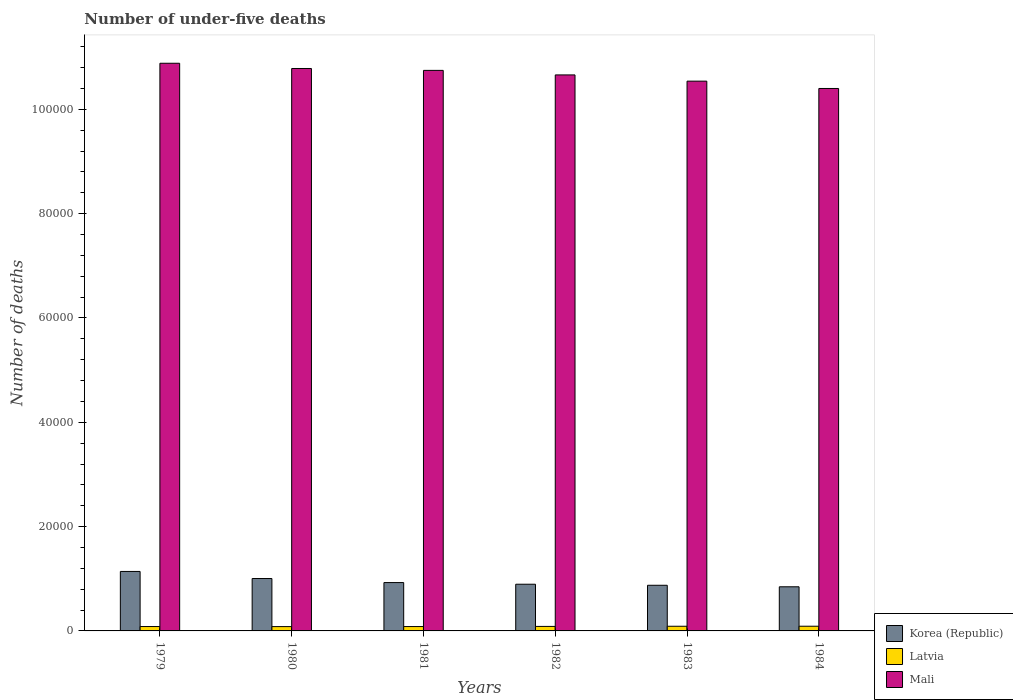Are the number of bars on each tick of the X-axis equal?
Your answer should be compact. Yes. How many bars are there on the 6th tick from the right?
Ensure brevity in your answer.  3. What is the label of the 1st group of bars from the left?
Provide a succinct answer. 1979. In how many cases, is the number of bars for a given year not equal to the number of legend labels?
Your response must be concise. 0. What is the number of under-five deaths in Latvia in 1980?
Your answer should be compact. 828. Across all years, what is the maximum number of under-five deaths in Korea (Republic)?
Offer a very short reply. 1.14e+04. Across all years, what is the minimum number of under-five deaths in Latvia?
Your answer should be compact. 828. In which year was the number of under-five deaths in Korea (Republic) maximum?
Your answer should be compact. 1979. In which year was the number of under-five deaths in Korea (Republic) minimum?
Ensure brevity in your answer.  1984. What is the total number of under-five deaths in Mali in the graph?
Offer a very short reply. 6.40e+05. What is the difference between the number of under-five deaths in Korea (Republic) in 1979 and that in 1984?
Give a very brief answer. 2941. What is the difference between the number of under-five deaths in Latvia in 1984 and the number of under-five deaths in Korea (Republic) in 1979?
Ensure brevity in your answer.  -1.05e+04. What is the average number of under-five deaths in Korea (Republic) per year?
Your response must be concise. 9480.67. In the year 1979, what is the difference between the number of under-five deaths in Mali and number of under-five deaths in Korea (Republic)?
Give a very brief answer. 9.74e+04. In how many years, is the number of under-five deaths in Mali greater than 68000?
Provide a succinct answer. 6. What is the ratio of the number of under-five deaths in Latvia in 1979 to that in 1982?
Provide a succinct answer. 0.97. Is the number of under-five deaths in Korea (Republic) in 1982 less than that in 1983?
Your answer should be very brief. No. Is the difference between the number of under-five deaths in Mali in 1983 and 1984 greater than the difference between the number of under-five deaths in Korea (Republic) in 1983 and 1984?
Offer a terse response. Yes. What is the difference between the highest and the second highest number of under-five deaths in Korea (Republic)?
Your answer should be very brief. 1359. What is the difference between the highest and the lowest number of under-five deaths in Latvia?
Your answer should be compact. 72. In how many years, is the number of under-five deaths in Latvia greater than the average number of under-five deaths in Latvia taken over all years?
Your answer should be very brief. 3. Is the sum of the number of under-five deaths in Latvia in 1979 and 1980 greater than the maximum number of under-five deaths in Mali across all years?
Ensure brevity in your answer.  No. What does the 2nd bar from the left in 1980 represents?
Make the answer very short. Latvia. How many years are there in the graph?
Your response must be concise. 6. Does the graph contain any zero values?
Your answer should be very brief. No. Does the graph contain grids?
Offer a terse response. No. Where does the legend appear in the graph?
Your answer should be compact. Bottom right. How are the legend labels stacked?
Keep it short and to the point. Vertical. What is the title of the graph?
Offer a very short reply. Number of under-five deaths. Does "Ecuador" appear as one of the legend labels in the graph?
Offer a very short reply. No. What is the label or title of the Y-axis?
Keep it short and to the point. Number of deaths. What is the Number of deaths of Korea (Republic) in 1979?
Provide a succinct answer. 1.14e+04. What is the Number of deaths of Latvia in 1979?
Give a very brief answer. 839. What is the Number of deaths of Mali in 1979?
Provide a succinct answer. 1.09e+05. What is the Number of deaths in Korea (Republic) in 1980?
Make the answer very short. 1.00e+04. What is the Number of deaths of Latvia in 1980?
Provide a succinct answer. 828. What is the Number of deaths in Mali in 1980?
Offer a very short reply. 1.08e+05. What is the Number of deaths in Korea (Republic) in 1981?
Provide a short and direct response. 9270. What is the Number of deaths of Latvia in 1981?
Offer a terse response. 836. What is the Number of deaths of Mali in 1981?
Your response must be concise. 1.07e+05. What is the Number of deaths of Korea (Republic) in 1982?
Offer a terse response. 8953. What is the Number of deaths of Latvia in 1982?
Offer a very short reply. 863. What is the Number of deaths in Mali in 1982?
Make the answer very short. 1.07e+05. What is the Number of deaths in Korea (Republic) in 1983?
Give a very brief answer. 8752. What is the Number of deaths of Latvia in 1983?
Provide a short and direct response. 893. What is the Number of deaths in Mali in 1983?
Your response must be concise. 1.05e+05. What is the Number of deaths of Korea (Republic) in 1984?
Make the answer very short. 8462. What is the Number of deaths of Latvia in 1984?
Keep it short and to the point. 900. What is the Number of deaths of Mali in 1984?
Offer a terse response. 1.04e+05. Across all years, what is the maximum Number of deaths of Korea (Republic)?
Give a very brief answer. 1.14e+04. Across all years, what is the maximum Number of deaths of Latvia?
Give a very brief answer. 900. Across all years, what is the maximum Number of deaths of Mali?
Make the answer very short. 1.09e+05. Across all years, what is the minimum Number of deaths of Korea (Republic)?
Ensure brevity in your answer.  8462. Across all years, what is the minimum Number of deaths in Latvia?
Your response must be concise. 828. Across all years, what is the minimum Number of deaths in Mali?
Your answer should be very brief. 1.04e+05. What is the total Number of deaths of Korea (Republic) in the graph?
Provide a succinct answer. 5.69e+04. What is the total Number of deaths of Latvia in the graph?
Give a very brief answer. 5159. What is the total Number of deaths in Mali in the graph?
Your answer should be very brief. 6.40e+05. What is the difference between the Number of deaths in Korea (Republic) in 1979 and that in 1980?
Keep it short and to the point. 1359. What is the difference between the Number of deaths in Latvia in 1979 and that in 1980?
Offer a terse response. 11. What is the difference between the Number of deaths of Mali in 1979 and that in 1980?
Your response must be concise. 1002. What is the difference between the Number of deaths of Korea (Republic) in 1979 and that in 1981?
Give a very brief answer. 2133. What is the difference between the Number of deaths in Latvia in 1979 and that in 1981?
Offer a very short reply. 3. What is the difference between the Number of deaths in Mali in 1979 and that in 1981?
Provide a succinct answer. 1365. What is the difference between the Number of deaths in Korea (Republic) in 1979 and that in 1982?
Give a very brief answer. 2450. What is the difference between the Number of deaths in Mali in 1979 and that in 1982?
Give a very brief answer. 2236. What is the difference between the Number of deaths of Korea (Republic) in 1979 and that in 1983?
Provide a short and direct response. 2651. What is the difference between the Number of deaths of Latvia in 1979 and that in 1983?
Offer a very short reply. -54. What is the difference between the Number of deaths in Mali in 1979 and that in 1983?
Make the answer very short. 3429. What is the difference between the Number of deaths in Korea (Republic) in 1979 and that in 1984?
Offer a very short reply. 2941. What is the difference between the Number of deaths of Latvia in 1979 and that in 1984?
Keep it short and to the point. -61. What is the difference between the Number of deaths of Mali in 1979 and that in 1984?
Ensure brevity in your answer.  4836. What is the difference between the Number of deaths of Korea (Republic) in 1980 and that in 1981?
Offer a terse response. 774. What is the difference between the Number of deaths in Mali in 1980 and that in 1981?
Your answer should be very brief. 363. What is the difference between the Number of deaths in Korea (Republic) in 1980 and that in 1982?
Your answer should be very brief. 1091. What is the difference between the Number of deaths of Latvia in 1980 and that in 1982?
Give a very brief answer. -35. What is the difference between the Number of deaths in Mali in 1980 and that in 1982?
Provide a succinct answer. 1234. What is the difference between the Number of deaths of Korea (Republic) in 1980 and that in 1983?
Give a very brief answer. 1292. What is the difference between the Number of deaths of Latvia in 1980 and that in 1983?
Make the answer very short. -65. What is the difference between the Number of deaths in Mali in 1980 and that in 1983?
Offer a very short reply. 2427. What is the difference between the Number of deaths of Korea (Republic) in 1980 and that in 1984?
Provide a succinct answer. 1582. What is the difference between the Number of deaths in Latvia in 1980 and that in 1984?
Your response must be concise. -72. What is the difference between the Number of deaths of Mali in 1980 and that in 1984?
Give a very brief answer. 3834. What is the difference between the Number of deaths in Korea (Republic) in 1981 and that in 1982?
Offer a terse response. 317. What is the difference between the Number of deaths in Latvia in 1981 and that in 1982?
Give a very brief answer. -27. What is the difference between the Number of deaths of Mali in 1981 and that in 1982?
Provide a succinct answer. 871. What is the difference between the Number of deaths of Korea (Republic) in 1981 and that in 1983?
Ensure brevity in your answer.  518. What is the difference between the Number of deaths of Latvia in 1981 and that in 1983?
Give a very brief answer. -57. What is the difference between the Number of deaths of Mali in 1981 and that in 1983?
Your answer should be very brief. 2064. What is the difference between the Number of deaths of Korea (Republic) in 1981 and that in 1984?
Your answer should be very brief. 808. What is the difference between the Number of deaths in Latvia in 1981 and that in 1984?
Provide a succinct answer. -64. What is the difference between the Number of deaths in Mali in 1981 and that in 1984?
Make the answer very short. 3471. What is the difference between the Number of deaths in Korea (Republic) in 1982 and that in 1983?
Your response must be concise. 201. What is the difference between the Number of deaths of Mali in 1982 and that in 1983?
Provide a short and direct response. 1193. What is the difference between the Number of deaths in Korea (Republic) in 1982 and that in 1984?
Your answer should be compact. 491. What is the difference between the Number of deaths in Latvia in 1982 and that in 1984?
Provide a short and direct response. -37. What is the difference between the Number of deaths of Mali in 1982 and that in 1984?
Your answer should be compact. 2600. What is the difference between the Number of deaths in Korea (Republic) in 1983 and that in 1984?
Give a very brief answer. 290. What is the difference between the Number of deaths in Mali in 1983 and that in 1984?
Ensure brevity in your answer.  1407. What is the difference between the Number of deaths in Korea (Republic) in 1979 and the Number of deaths in Latvia in 1980?
Offer a terse response. 1.06e+04. What is the difference between the Number of deaths in Korea (Republic) in 1979 and the Number of deaths in Mali in 1980?
Offer a very short reply. -9.64e+04. What is the difference between the Number of deaths in Latvia in 1979 and the Number of deaths in Mali in 1980?
Your answer should be very brief. -1.07e+05. What is the difference between the Number of deaths of Korea (Republic) in 1979 and the Number of deaths of Latvia in 1981?
Provide a succinct answer. 1.06e+04. What is the difference between the Number of deaths in Korea (Republic) in 1979 and the Number of deaths in Mali in 1981?
Provide a short and direct response. -9.61e+04. What is the difference between the Number of deaths in Latvia in 1979 and the Number of deaths in Mali in 1981?
Your answer should be compact. -1.07e+05. What is the difference between the Number of deaths of Korea (Republic) in 1979 and the Number of deaths of Latvia in 1982?
Provide a short and direct response. 1.05e+04. What is the difference between the Number of deaths in Korea (Republic) in 1979 and the Number of deaths in Mali in 1982?
Keep it short and to the point. -9.52e+04. What is the difference between the Number of deaths of Latvia in 1979 and the Number of deaths of Mali in 1982?
Provide a short and direct response. -1.06e+05. What is the difference between the Number of deaths of Korea (Republic) in 1979 and the Number of deaths of Latvia in 1983?
Offer a terse response. 1.05e+04. What is the difference between the Number of deaths in Korea (Republic) in 1979 and the Number of deaths in Mali in 1983?
Provide a succinct answer. -9.40e+04. What is the difference between the Number of deaths of Latvia in 1979 and the Number of deaths of Mali in 1983?
Provide a short and direct response. -1.05e+05. What is the difference between the Number of deaths of Korea (Republic) in 1979 and the Number of deaths of Latvia in 1984?
Ensure brevity in your answer.  1.05e+04. What is the difference between the Number of deaths in Korea (Republic) in 1979 and the Number of deaths in Mali in 1984?
Provide a succinct answer. -9.26e+04. What is the difference between the Number of deaths of Latvia in 1979 and the Number of deaths of Mali in 1984?
Make the answer very short. -1.03e+05. What is the difference between the Number of deaths in Korea (Republic) in 1980 and the Number of deaths in Latvia in 1981?
Your answer should be compact. 9208. What is the difference between the Number of deaths of Korea (Republic) in 1980 and the Number of deaths of Mali in 1981?
Make the answer very short. -9.74e+04. What is the difference between the Number of deaths of Latvia in 1980 and the Number of deaths of Mali in 1981?
Provide a short and direct response. -1.07e+05. What is the difference between the Number of deaths in Korea (Republic) in 1980 and the Number of deaths in Latvia in 1982?
Provide a succinct answer. 9181. What is the difference between the Number of deaths of Korea (Republic) in 1980 and the Number of deaths of Mali in 1982?
Offer a terse response. -9.65e+04. What is the difference between the Number of deaths in Latvia in 1980 and the Number of deaths in Mali in 1982?
Give a very brief answer. -1.06e+05. What is the difference between the Number of deaths in Korea (Republic) in 1980 and the Number of deaths in Latvia in 1983?
Your answer should be very brief. 9151. What is the difference between the Number of deaths of Korea (Republic) in 1980 and the Number of deaths of Mali in 1983?
Make the answer very short. -9.54e+04. What is the difference between the Number of deaths of Latvia in 1980 and the Number of deaths of Mali in 1983?
Keep it short and to the point. -1.05e+05. What is the difference between the Number of deaths in Korea (Republic) in 1980 and the Number of deaths in Latvia in 1984?
Make the answer very short. 9144. What is the difference between the Number of deaths of Korea (Republic) in 1980 and the Number of deaths of Mali in 1984?
Give a very brief answer. -9.39e+04. What is the difference between the Number of deaths in Latvia in 1980 and the Number of deaths in Mali in 1984?
Offer a very short reply. -1.03e+05. What is the difference between the Number of deaths of Korea (Republic) in 1981 and the Number of deaths of Latvia in 1982?
Make the answer very short. 8407. What is the difference between the Number of deaths in Korea (Republic) in 1981 and the Number of deaths in Mali in 1982?
Make the answer very short. -9.73e+04. What is the difference between the Number of deaths in Latvia in 1981 and the Number of deaths in Mali in 1982?
Offer a very short reply. -1.06e+05. What is the difference between the Number of deaths of Korea (Republic) in 1981 and the Number of deaths of Latvia in 1983?
Provide a short and direct response. 8377. What is the difference between the Number of deaths of Korea (Republic) in 1981 and the Number of deaths of Mali in 1983?
Ensure brevity in your answer.  -9.61e+04. What is the difference between the Number of deaths of Latvia in 1981 and the Number of deaths of Mali in 1983?
Provide a succinct answer. -1.05e+05. What is the difference between the Number of deaths in Korea (Republic) in 1981 and the Number of deaths in Latvia in 1984?
Give a very brief answer. 8370. What is the difference between the Number of deaths of Korea (Republic) in 1981 and the Number of deaths of Mali in 1984?
Give a very brief answer. -9.47e+04. What is the difference between the Number of deaths in Latvia in 1981 and the Number of deaths in Mali in 1984?
Your response must be concise. -1.03e+05. What is the difference between the Number of deaths in Korea (Republic) in 1982 and the Number of deaths in Latvia in 1983?
Provide a short and direct response. 8060. What is the difference between the Number of deaths of Korea (Republic) in 1982 and the Number of deaths of Mali in 1983?
Your answer should be very brief. -9.64e+04. What is the difference between the Number of deaths of Latvia in 1982 and the Number of deaths of Mali in 1983?
Offer a terse response. -1.05e+05. What is the difference between the Number of deaths of Korea (Republic) in 1982 and the Number of deaths of Latvia in 1984?
Your answer should be very brief. 8053. What is the difference between the Number of deaths in Korea (Republic) in 1982 and the Number of deaths in Mali in 1984?
Your answer should be very brief. -9.50e+04. What is the difference between the Number of deaths of Latvia in 1982 and the Number of deaths of Mali in 1984?
Provide a short and direct response. -1.03e+05. What is the difference between the Number of deaths in Korea (Republic) in 1983 and the Number of deaths in Latvia in 1984?
Offer a very short reply. 7852. What is the difference between the Number of deaths of Korea (Republic) in 1983 and the Number of deaths of Mali in 1984?
Keep it short and to the point. -9.52e+04. What is the difference between the Number of deaths in Latvia in 1983 and the Number of deaths in Mali in 1984?
Your answer should be very brief. -1.03e+05. What is the average Number of deaths in Korea (Republic) per year?
Offer a very short reply. 9480.67. What is the average Number of deaths in Latvia per year?
Give a very brief answer. 859.83. What is the average Number of deaths in Mali per year?
Give a very brief answer. 1.07e+05. In the year 1979, what is the difference between the Number of deaths in Korea (Republic) and Number of deaths in Latvia?
Provide a short and direct response. 1.06e+04. In the year 1979, what is the difference between the Number of deaths of Korea (Republic) and Number of deaths of Mali?
Your answer should be very brief. -9.74e+04. In the year 1979, what is the difference between the Number of deaths of Latvia and Number of deaths of Mali?
Keep it short and to the point. -1.08e+05. In the year 1980, what is the difference between the Number of deaths of Korea (Republic) and Number of deaths of Latvia?
Make the answer very short. 9216. In the year 1980, what is the difference between the Number of deaths in Korea (Republic) and Number of deaths in Mali?
Provide a succinct answer. -9.78e+04. In the year 1980, what is the difference between the Number of deaths in Latvia and Number of deaths in Mali?
Your answer should be compact. -1.07e+05. In the year 1981, what is the difference between the Number of deaths of Korea (Republic) and Number of deaths of Latvia?
Provide a short and direct response. 8434. In the year 1981, what is the difference between the Number of deaths of Korea (Republic) and Number of deaths of Mali?
Provide a succinct answer. -9.82e+04. In the year 1981, what is the difference between the Number of deaths of Latvia and Number of deaths of Mali?
Provide a short and direct response. -1.07e+05. In the year 1982, what is the difference between the Number of deaths in Korea (Republic) and Number of deaths in Latvia?
Give a very brief answer. 8090. In the year 1982, what is the difference between the Number of deaths of Korea (Republic) and Number of deaths of Mali?
Your response must be concise. -9.76e+04. In the year 1982, what is the difference between the Number of deaths of Latvia and Number of deaths of Mali?
Provide a succinct answer. -1.06e+05. In the year 1983, what is the difference between the Number of deaths of Korea (Republic) and Number of deaths of Latvia?
Make the answer very short. 7859. In the year 1983, what is the difference between the Number of deaths of Korea (Republic) and Number of deaths of Mali?
Your response must be concise. -9.66e+04. In the year 1983, what is the difference between the Number of deaths of Latvia and Number of deaths of Mali?
Make the answer very short. -1.05e+05. In the year 1984, what is the difference between the Number of deaths in Korea (Republic) and Number of deaths in Latvia?
Provide a succinct answer. 7562. In the year 1984, what is the difference between the Number of deaths in Korea (Republic) and Number of deaths in Mali?
Your answer should be compact. -9.55e+04. In the year 1984, what is the difference between the Number of deaths in Latvia and Number of deaths in Mali?
Offer a very short reply. -1.03e+05. What is the ratio of the Number of deaths in Korea (Republic) in 1979 to that in 1980?
Provide a short and direct response. 1.14. What is the ratio of the Number of deaths in Latvia in 1979 to that in 1980?
Offer a terse response. 1.01. What is the ratio of the Number of deaths of Mali in 1979 to that in 1980?
Your response must be concise. 1.01. What is the ratio of the Number of deaths in Korea (Republic) in 1979 to that in 1981?
Give a very brief answer. 1.23. What is the ratio of the Number of deaths of Latvia in 1979 to that in 1981?
Offer a very short reply. 1. What is the ratio of the Number of deaths of Mali in 1979 to that in 1981?
Offer a very short reply. 1.01. What is the ratio of the Number of deaths of Korea (Republic) in 1979 to that in 1982?
Your answer should be compact. 1.27. What is the ratio of the Number of deaths in Latvia in 1979 to that in 1982?
Give a very brief answer. 0.97. What is the ratio of the Number of deaths in Korea (Republic) in 1979 to that in 1983?
Offer a very short reply. 1.3. What is the ratio of the Number of deaths of Latvia in 1979 to that in 1983?
Your answer should be very brief. 0.94. What is the ratio of the Number of deaths of Mali in 1979 to that in 1983?
Make the answer very short. 1.03. What is the ratio of the Number of deaths of Korea (Republic) in 1979 to that in 1984?
Offer a terse response. 1.35. What is the ratio of the Number of deaths in Latvia in 1979 to that in 1984?
Your response must be concise. 0.93. What is the ratio of the Number of deaths in Mali in 1979 to that in 1984?
Offer a terse response. 1.05. What is the ratio of the Number of deaths of Korea (Republic) in 1980 to that in 1981?
Offer a terse response. 1.08. What is the ratio of the Number of deaths of Mali in 1980 to that in 1981?
Ensure brevity in your answer.  1. What is the ratio of the Number of deaths of Korea (Republic) in 1980 to that in 1982?
Your response must be concise. 1.12. What is the ratio of the Number of deaths of Latvia in 1980 to that in 1982?
Ensure brevity in your answer.  0.96. What is the ratio of the Number of deaths in Mali in 1980 to that in 1982?
Offer a terse response. 1.01. What is the ratio of the Number of deaths of Korea (Republic) in 1980 to that in 1983?
Your answer should be very brief. 1.15. What is the ratio of the Number of deaths of Latvia in 1980 to that in 1983?
Keep it short and to the point. 0.93. What is the ratio of the Number of deaths in Korea (Republic) in 1980 to that in 1984?
Make the answer very short. 1.19. What is the ratio of the Number of deaths of Mali in 1980 to that in 1984?
Offer a terse response. 1.04. What is the ratio of the Number of deaths of Korea (Republic) in 1981 to that in 1982?
Your response must be concise. 1.04. What is the ratio of the Number of deaths in Latvia in 1981 to that in 1982?
Your answer should be very brief. 0.97. What is the ratio of the Number of deaths of Mali in 1981 to that in 1982?
Provide a short and direct response. 1.01. What is the ratio of the Number of deaths in Korea (Republic) in 1981 to that in 1983?
Provide a short and direct response. 1.06. What is the ratio of the Number of deaths in Latvia in 1981 to that in 1983?
Keep it short and to the point. 0.94. What is the ratio of the Number of deaths of Mali in 1981 to that in 1983?
Give a very brief answer. 1.02. What is the ratio of the Number of deaths of Korea (Republic) in 1981 to that in 1984?
Keep it short and to the point. 1.1. What is the ratio of the Number of deaths of Latvia in 1981 to that in 1984?
Ensure brevity in your answer.  0.93. What is the ratio of the Number of deaths in Mali in 1981 to that in 1984?
Provide a succinct answer. 1.03. What is the ratio of the Number of deaths in Latvia in 1982 to that in 1983?
Your response must be concise. 0.97. What is the ratio of the Number of deaths in Mali in 1982 to that in 1983?
Your answer should be compact. 1.01. What is the ratio of the Number of deaths in Korea (Republic) in 1982 to that in 1984?
Make the answer very short. 1.06. What is the ratio of the Number of deaths of Latvia in 1982 to that in 1984?
Provide a succinct answer. 0.96. What is the ratio of the Number of deaths of Mali in 1982 to that in 1984?
Offer a terse response. 1.02. What is the ratio of the Number of deaths of Korea (Republic) in 1983 to that in 1984?
Your answer should be very brief. 1.03. What is the ratio of the Number of deaths of Mali in 1983 to that in 1984?
Your answer should be very brief. 1.01. What is the difference between the highest and the second highest Number of deaths in Korea (Republic)?
Your answer should be very brief. 1359. What is the difference between the highest and the second highest Number of deaths of Mali?
Make the answer very short. 1002. What is the difference between the highest and the lowest Number of deaths in Korea (Republic)?
Make the answer very short. 2941. What is the difference between the highest and the lowest Number of deaths in Latvia?
Your answer should be very brief. 72. What is the difference between the highest and the lowest Number of deaths in Mali?
Your response must be concise. 4836. 